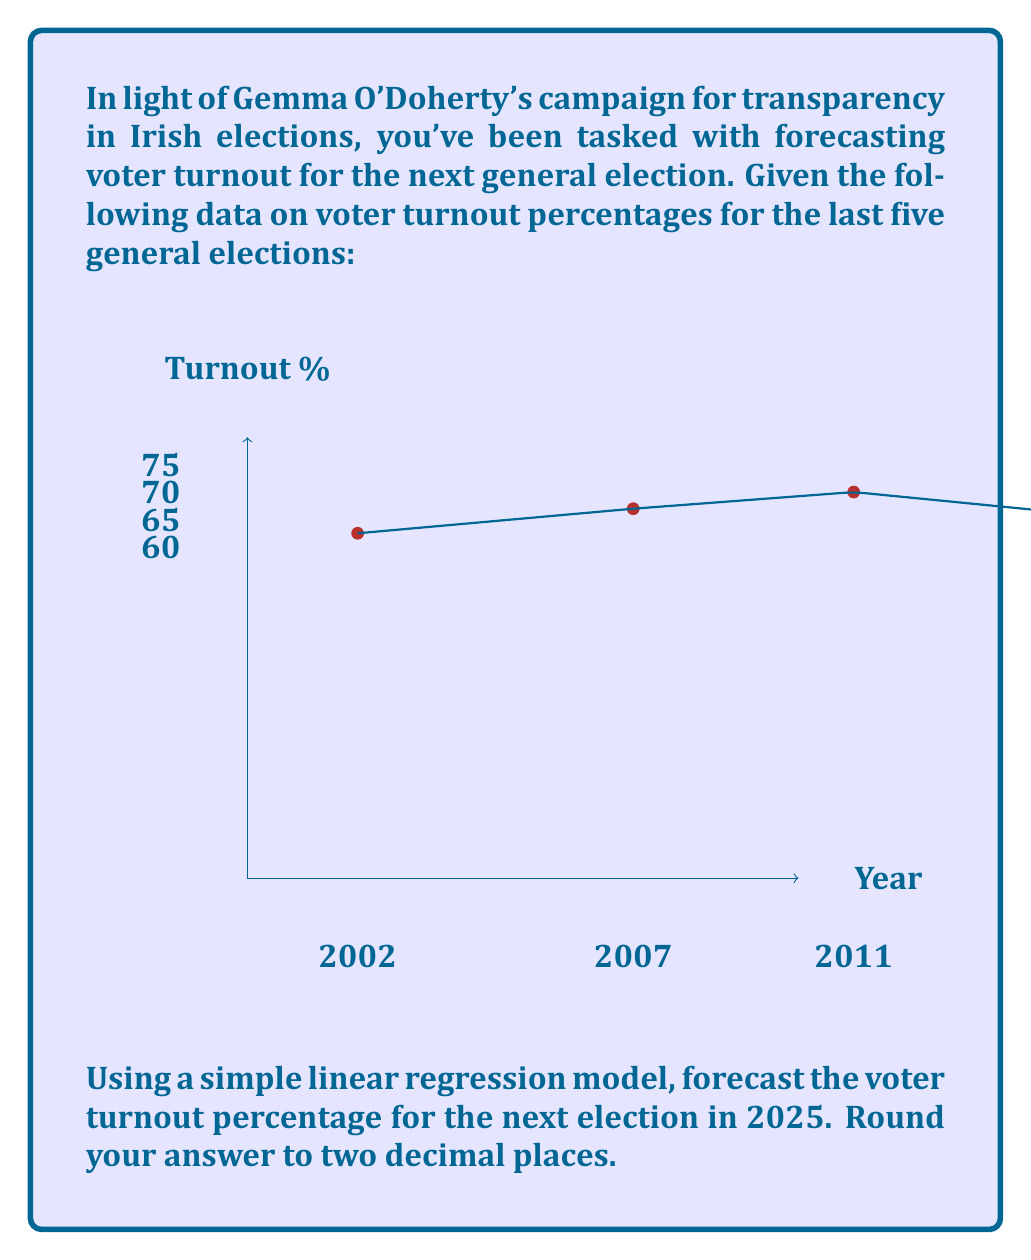Show me your answer to this math problem. To forecast the voter turnout for 2025 using simple linear regression, we'll follow these steps:

1) Let $x$ represent the year and $y$ represent the turnout percentage.

2) Calculate the means of $x$ and $y$:
   $\bar{x} = \frac{2002 + 2007 + 2011 + 2016 + 2020}{5} = 2011.2$
   $\bar{y} = \frac{62.57 + 67.03 + 70.05 + 65.14 + 62.90}{5} = 65.538$

3) Calculate the slope $b$ of the regression line:
   $b = \frac{\sum(x_i - \bar{x})(y_i - \bar{y})}{\sum(x_i - \bar{x})^2}$

4) Simplify this calculation:
   $b = \frac{(-9.2 \times -2.968) + (-4.2 \times 1.492) + (-0.2 \times 4.512) + (4.8 \times -0.398) + (8.8 \times -2.638)}{(-9.2)^2 + (-4.2)^2 + (-0.2)^2 + (4.8)^2 + (8.8)^2}$
   $b = \frac{27.3056 - 6.2664 - 0.9024 - 1.9104 - 23.2144}{84.64 + 17.64 + 0.04 + 23.04 + 77.44}$
   $b = \frac{-4.988}{202.8} = -0.0246$

5) Calculate the y-intercept $a$:
   $a = \bar{y} - b\bar{x} = 65.538 - (-0.0246 \times 2011.2) = 114.9697$

6) The regression line equation is:
   $y = -0.0246x + 114.9697$

7) To forecast for 2025, substitute $x = 2025$:
   $y = -0.0246(2025) + 114.9697 = 65.1897$

8) Rounding to two decimal places: 65.19
Answer: 65.19% 